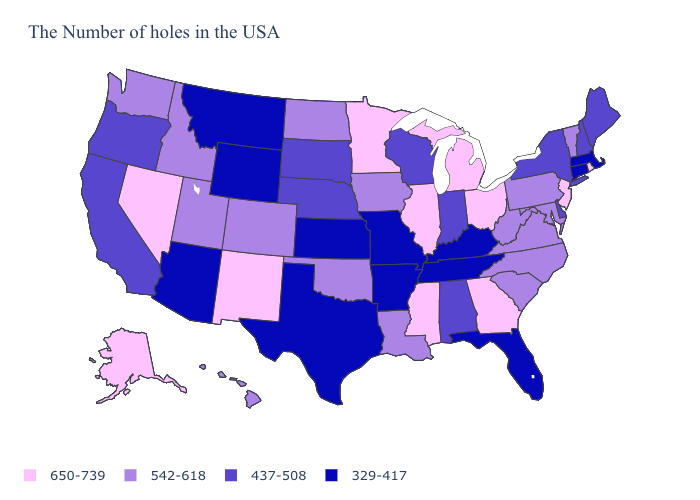Among the states that border New Mexico , which have the highest value?
Write a very short answer. Oklahoma, Colorado, Utah. Name the states that have a value in the range 437-508?
Write a very short answer. Maine, New Hampshire, New York, Delaware, Indiana, Alabama, Wisconsin, Nebraska, South Dakota, California, Oregon. Among the states that border Arkansas , which have the lowest value?
Write a very short answer. Tennessee, Missouri, Texas. What is the value of Ohio?
Give a very brief answer. 650-739. Name the states that have a value in the range 650-739?
Answer briefly. Rhode Island, New Jersey, Ohio, Georgia, Michigan, Illinois, Mississippi, Minnesota, New Mexico, Nevada, Alaska. What is the lowest value in the West?
Be succinct. 329-417. Does the first symbol in the legend represent the smallest category?
Quick response, please. No. Name the states that have a value in the range 542-618?
Short answer required. Vermont, Maryland, Pennsylvania, Virginia, North Carolina, South Carolina, West Virginia, Louisiana, Iowa, Oklahoma, North Dakota, Colorado, Utah, Idaho, Washington, Hawaii. Name the states that have a value in the range 329-417?
Short answer required. Massachusetts, Connecticut, Florida, Kentucky, Tennessee, Missouri, Arkansas, Kansas, Texas, Wyoming, Montana, Arizona. Name the states that have a value in the range 437-508?
Concise answer only. Maine, New Hampshire, New York, Delaware, Indiana, Alabama, Wisconsin, Nebraska, South Dakota, California, Oregon. What is the lowest value in the USA?
Give a very brief answer. 329-417. What is the value of Oregon?
Give a very brief answer. 437-508. Which states have the lowest value in the South?
Concise answer only. Florida, Kentucky, Tennessee, Arkansas, Texas. What is the value of Iowa?
Be succinct. 542-618. Does Minnesota have the highest value in the USA?
Give a very brief answer. Yes. 